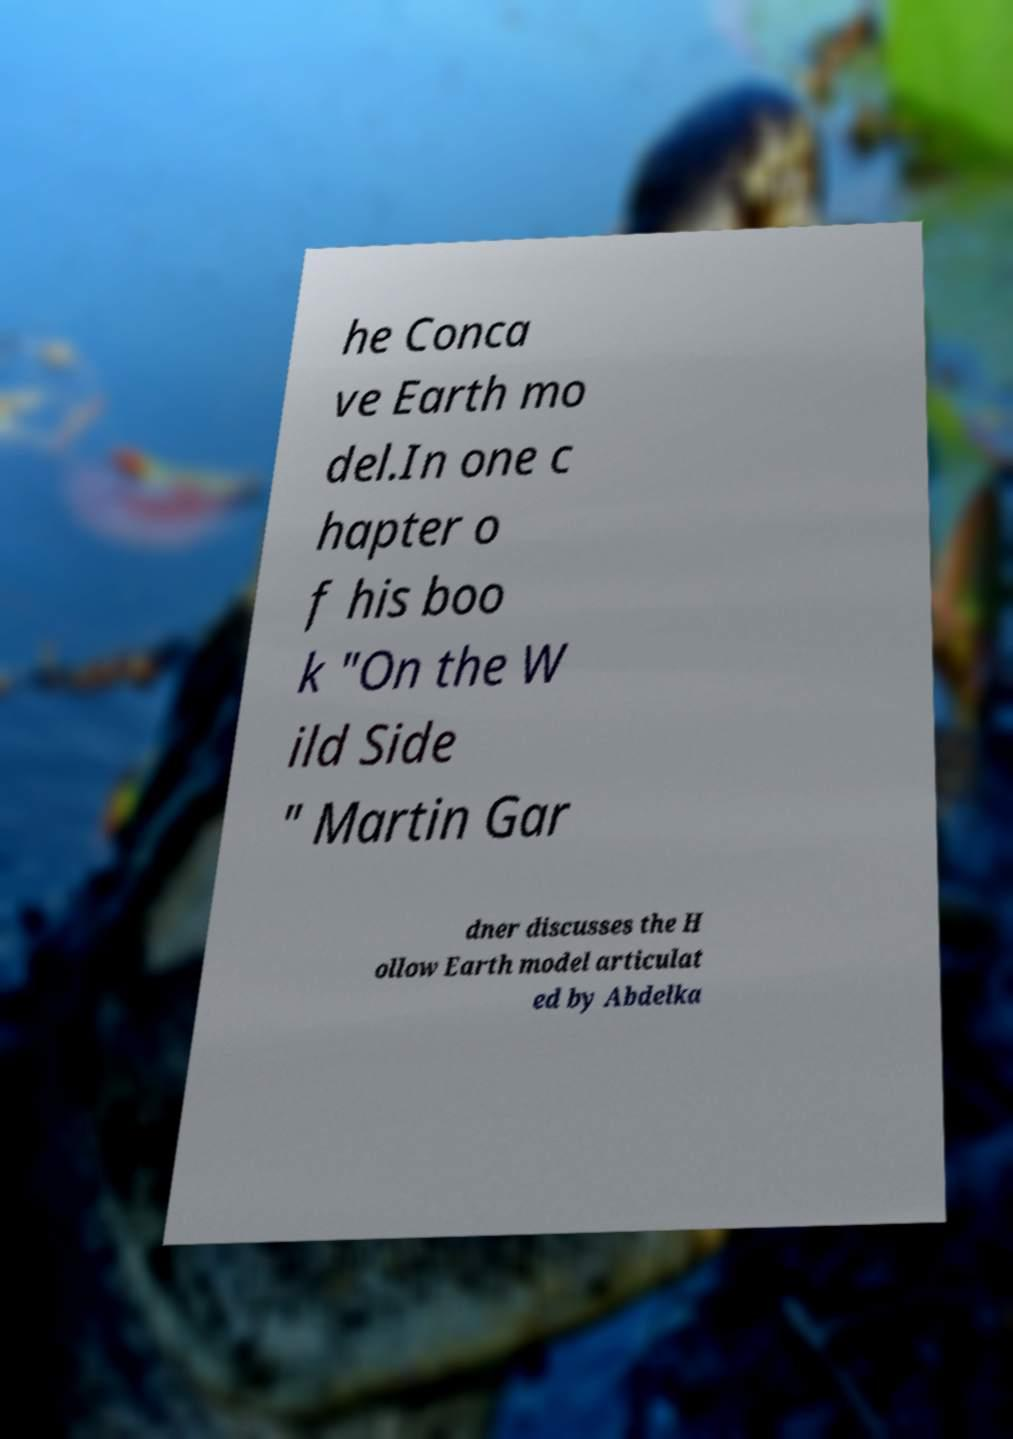Could you extract and type out the text from this image? he Conca ve Earth mo del.In one c hapter o f his boo k "On the W ild Side " Martin Gar dner discusses the H ollow Earth model articulat ed by Abdelka 